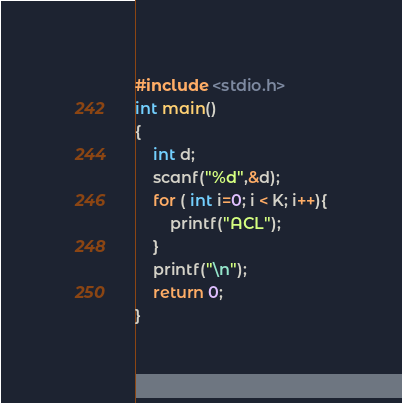Convert code to text. <code><loc_0><loc_0><loc_500><loc_500><_C_>#include <stdio.h>
int main()
{
    int d;
    scanf("%d",&d);
    for ( int i=0; i < K; i++){
        printf("ACL");
    }
    printf("\n");
    return 0;
}</code> 